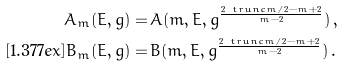<formula> <loc_0><loc_0><loc_500><loc_500>A _ { m } ( E , g ) = & \, A ( m , E , g ^ { \frac { 2 \ t r u n c { m / 2 } - m + 2 } { m - 2 } } ) \, , \\ [ 1 . 3 7 7 e x ] B _ { m } ( E , g ) = & \, B ( m , E , g ^ { \frac { 2 \ t r u n c { m / 2 } - m + 2 } { m - 2 } } ) \, .</formula> 